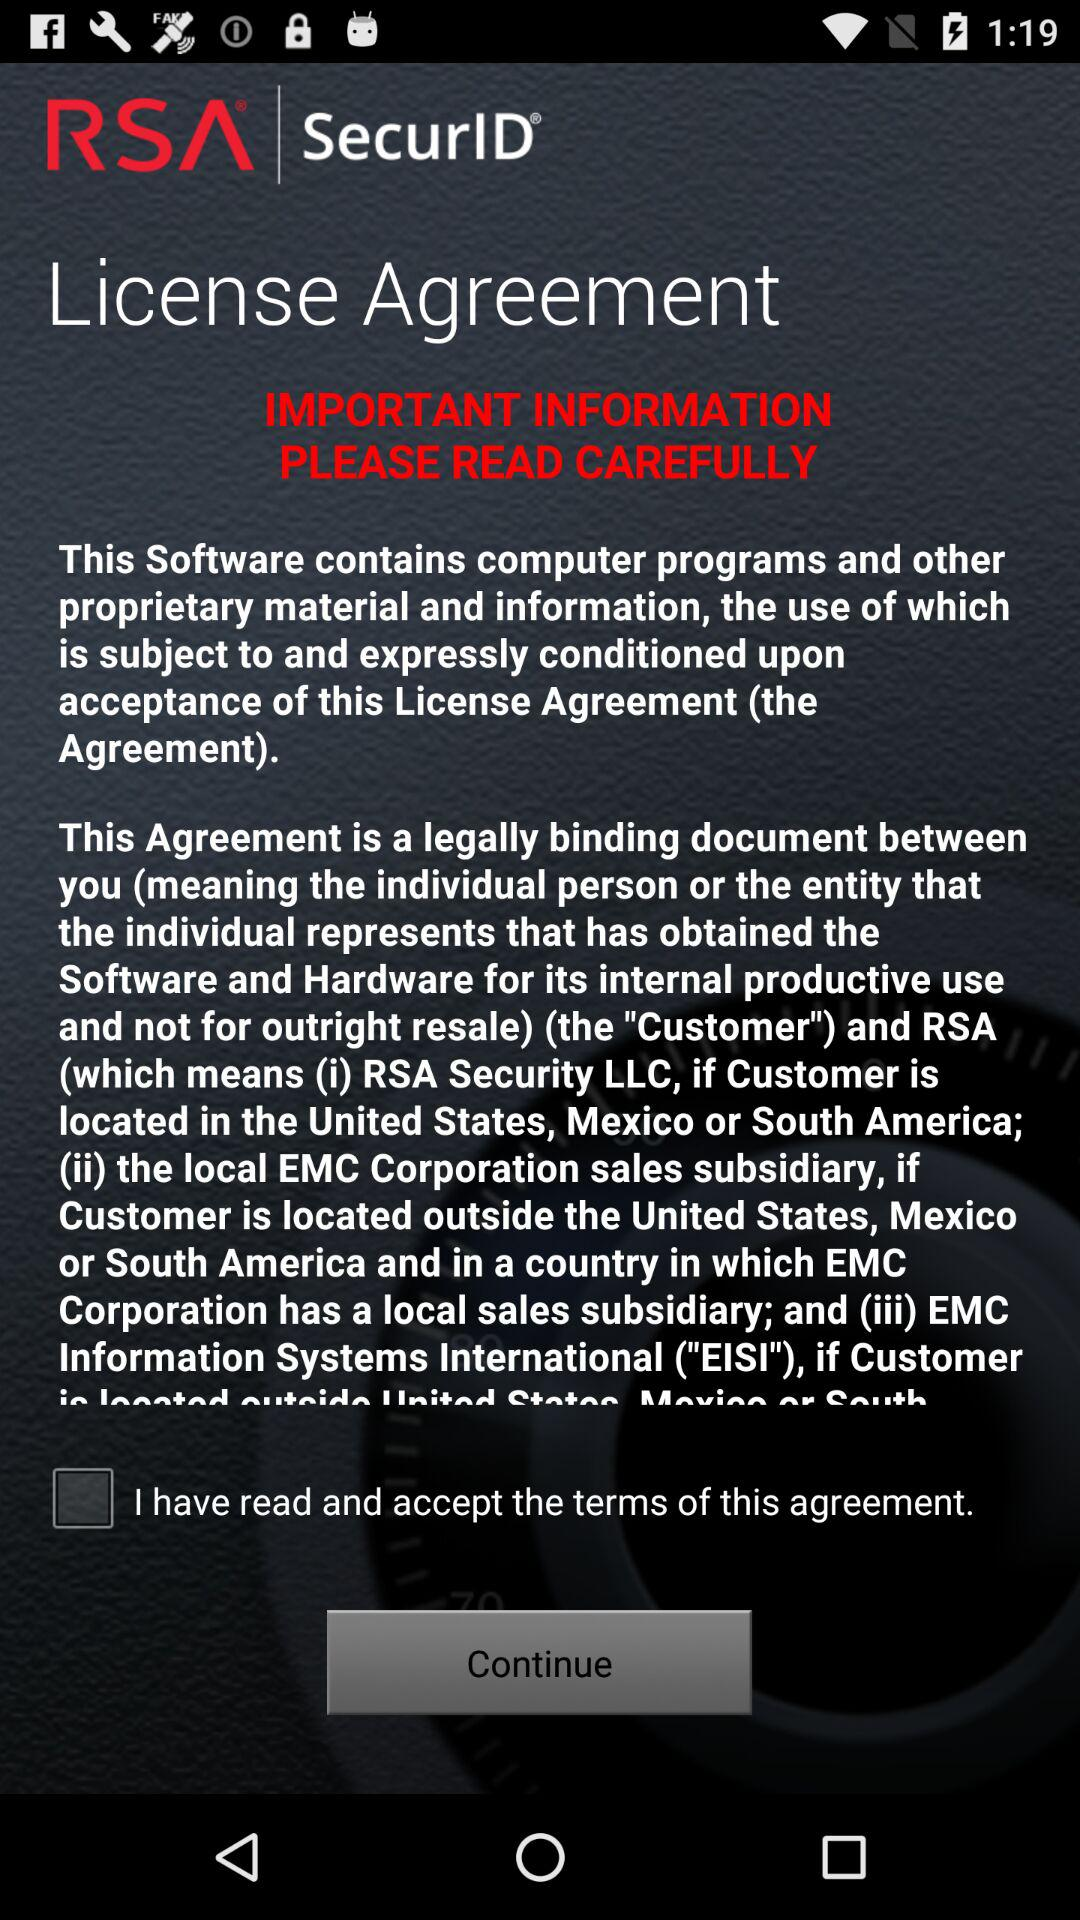What is the status of "I have read and accept the terms of this agreement"? The status is "off". 